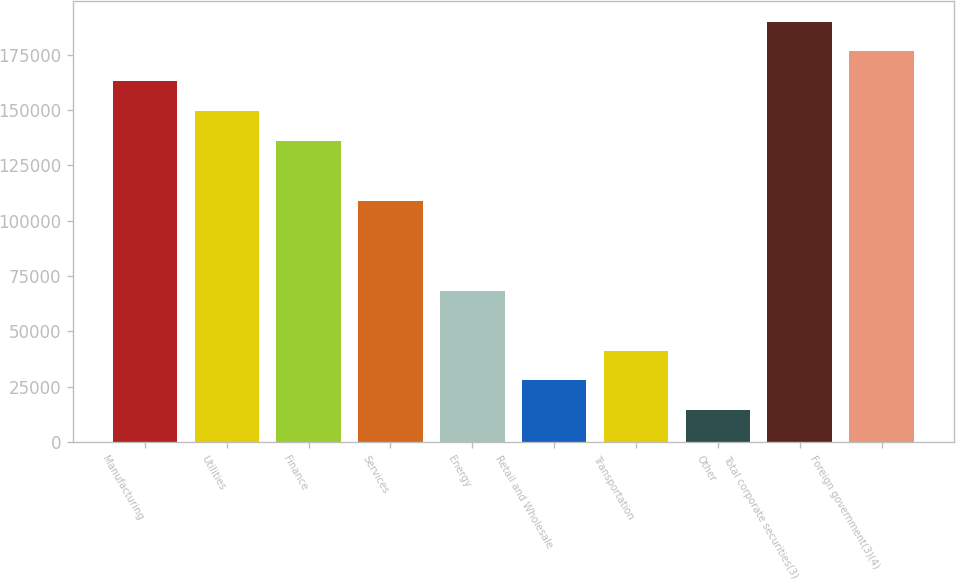Convert chart. <chart><loc_0><loc_0><loc_500><loc_500><bar_chart><fcel>Manufacturing<fcel>Utilities<fcel>Finance<fcel>Services<fcel>Energy<fcel>Retail and Wholesale<fcel>Transportation<fcel>Other<fcel>Total corporate securities(3)<fcel>Foreign government(3)(4)<nl><fcel>162910<fcel>149400<fcel>135890<fcel>108870<fcel>68339<fcel>27808.4<fcel>41318.6<fcel>14298.2<fcel>189931<fcel>176421<nl></chart> 